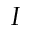Convert formula to latex. <formula><loc_0><loc_0><loc_500><loc_500>I</formula> 